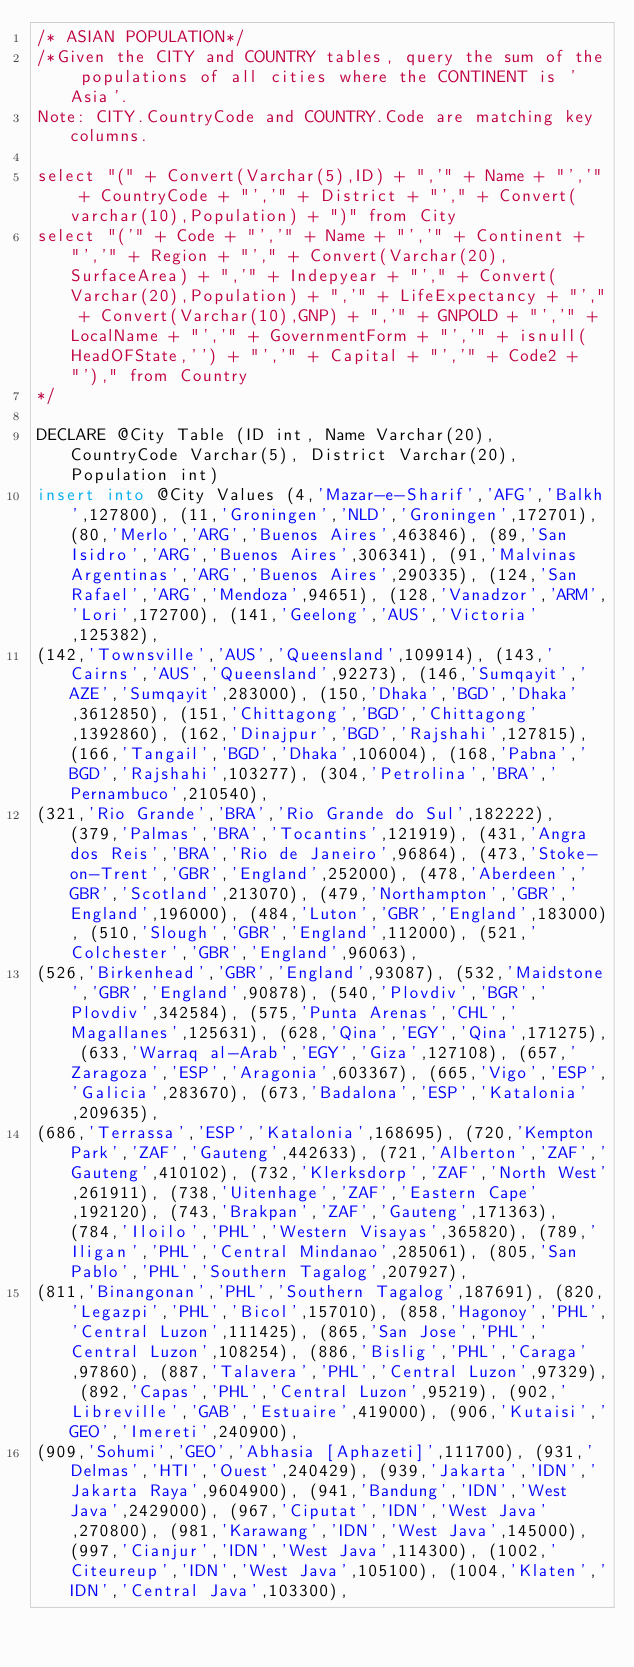<code> <loc_0><loc_0><loc_500><loc_500><_SQL_>/* ASIAN POPULATION*/
/*Given the CITY and COUNTRY tables, query the sum of the populations of all cities where the CONTINENT is 'Asia'.
Note: CITY.CountryCode and COUNTRY.Code are matching key columns.

select "(" + Convert(Varchar(5),ID) + ",'" + Name + "','" + CountryCode + "','" + District + "'," + Convert(varchar(10),Population) + ")" from City
select "('" + Code + "','" + Name + "','" + Continent + "','" + Region + "'," + Convert(Varchar(20),SurfaceArea) + ",'" + Indepyear + "'," + Convert(Varchar(20),Population) + ",'" + LifeExpectancy + "'," + Convert(Varchar(10),GNP) + ",'" + GNPOLD + "','" + LocalName + "','" + GovernmentForm + "','" + isnull(HeadOFState,'') + "','" + Capital + "','" + Code2 + "')," from Country
*/

DECLARE @City Table (ID int, Name Varchar(20), CountryCode Varchar(5), District Varchar(20), Population int)
insert into @City Values (4,'Mazar-e-Sharif','AFG','Balkh',127800), (11,'Groningen','NLD','Groningen',172701), (80,'Merlo','ARG','Buenos Aires',463846), (89,'San Isidro','ARG','Buenos Aires',306341), (91,'Malvinas Argentinas','ARG','Buenos Aires',290335), (124,'San Rafael','ARG','Mendoza',94651), (128,'Vanadzor','ARM','Lori',172700), (141,'Geelong','AUS','Victoria',125382), 
(142,'Townsville','AUS','Queensland',109914), (143,'Cairns','AUS','Queensland',92273), (146,'Sumqayit','AZE','Sumqayit',283000), (150,'Dhaka','BGD','Dhaka',3612850), (151,'Chittagong','BGD','Chittagong',1392860), (162,'Dinajpur','BGD','Rajshahi',127815), (166,'Tangail','BGD','Dhaka',106004), (168,'Pabna','BGD','Rajshahi',103277), (304,'Petrolina','BRA','Pernambuco',210540), 
(321,'Rio Grande','BRA','Rio Grande do Sul',182222), (379,'Palmas','BRA','Tocantins',121919), (431,'Angra dos Reis','BRA','Rio de Janeiro',96864), (473,'Stoke-on-Trent','GBR','England',252000), (478,'Aberdeen','GBR','Scotland',213070), (479,'Northampton','GBR','England',196000), (484,'Luton','GBR','England',183000), (510,'Slough','GBR','England',112000), (521,'Colchester','GBR','England',96063), 
(526,'Birkenhead','GBR','England',93087), (532,'Maidstone','GBR','England',90878), (540,'Plovdiv','BGR','Plovdiv',342584), (575,'Punta Arenas','CHL','Magallanes',125631), (628,'Qina','EGY','Qina',171275), (633,'Warraq al-Arab','EGY','Giza',127108), (657,'Zaragoza','ESP','Aragonia',603367), (665,'Vigo','ESP','Galicia',283670), (673,'Badalona','ESP','Katalonia',209635), 
(686,'Terrassa','ESP','Katalonia',168695), (720,'Kempton Park','ZAF','Gauteng',442633), (721,'Alberton','ZAF','Gauteng',410102), (732,'Klerksdorp','ZAF','North West',261911), (738,'Uitenhage','ZAF','Eastern Cape',192120), (743,'Brakpan','ZAF','Gauteng',171363), (784,'Iloilo','PHL','Western Visayas',365820), (789,'Iligan','PHL','Central Mindanao',285061), (805,'San Pablo','PHL','Southern Tagalog',207927), 
(811,'Binangonan','PHL','Southern Tagalog',187691), (820,'Legazpi','PHL','Bicol',157010), (858,'Hagonoy','PHL','Central Luzon',111425), (865,'San Jose','PHL','Central Luzon',108254), (886,'Bislig','PHL','Caraga',97860), (887,'Talavera','PHL','Central Luzon',97329), (892,'Capas','PHL','Central Luzon',95219), (902,'Libreville','GAB','Estuaire',419000), (906,'Kutaisi','GEO','Imereti',240900), 
(909,'Sohumi','GEO','Abhasia [Aphazeti]',111700), (931,'Delmas','HTI','Ouest',240429), (939,'Jakarta','IDN','Jakarta Raya',9604900), (941,'Bandung','IDN','West Java',2429000), (967,'Ciputat','IDN','West Java',270800), (981,'Karawang','IDN','West Java',145000), (997,'Cianjur','IDN','West Java',114300), (1002,'Citeureup','IDN','West Java',105100), (1004,'Klaten','IDN','Central Java',103300), </code> 